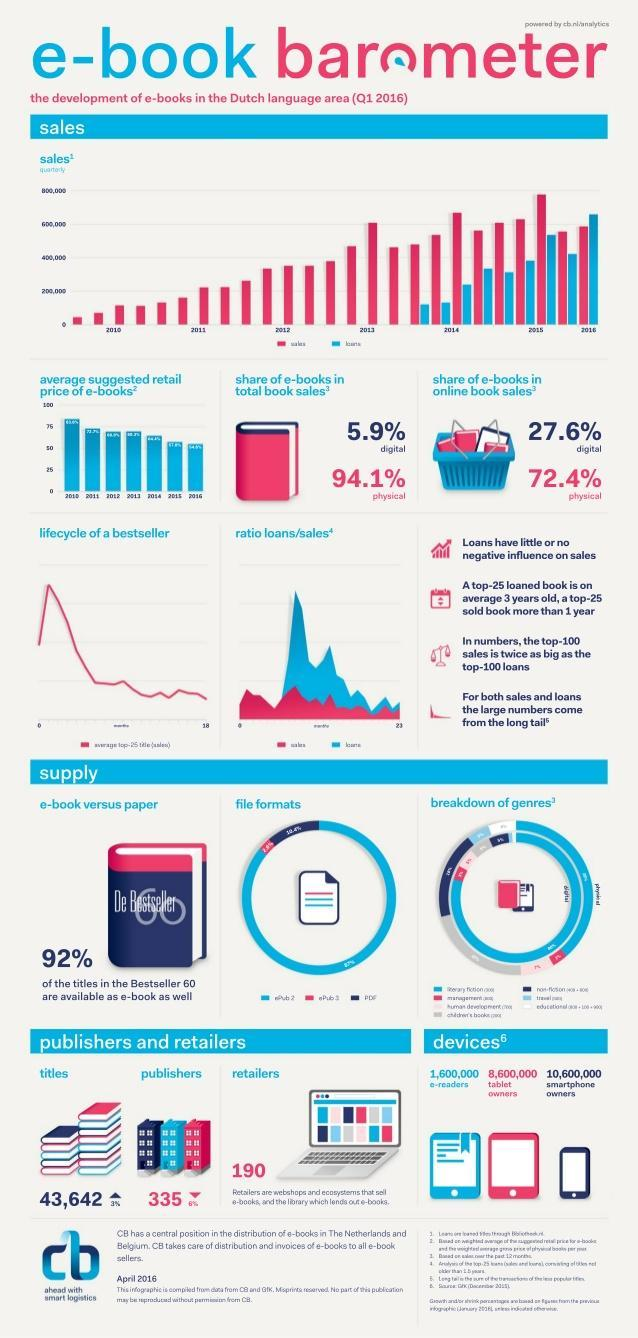What is the percentage decrease in the e-book publishers in Q1 2016?
Answer the question with a short phrase. 6% What is the share of physical books in total book sales in Q1 2016? 94.1% What is the percentage increase in the e-book titles in Q1 2016? 3% What is the share of e-books in online book sales in Q1 2016? 27.6% What is the number of retailers that sell e-books in Q1 2016? 190 What is the share of e-books in total book sales in Q1 2016? 5.9% 